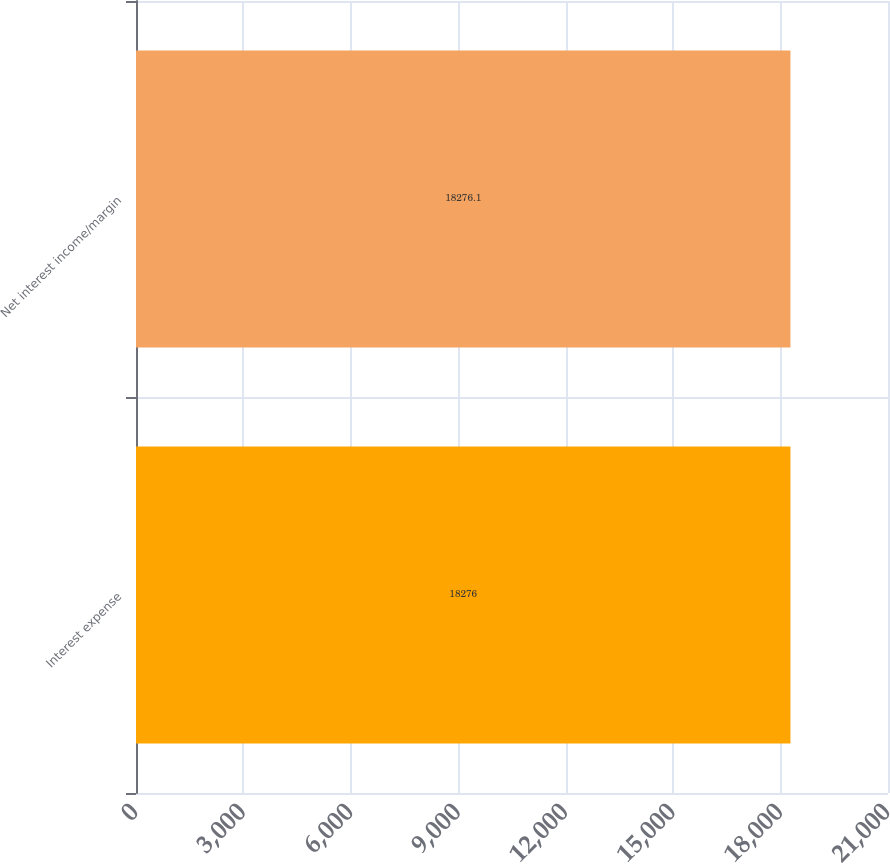<chart> <loc_0><loc_0><loc_500><loc_500><bar_chart><fcel>Interest expense<fcel>Net interest income/margin<nl><fcel>18276<fcel>18276.1<nl></chart> 